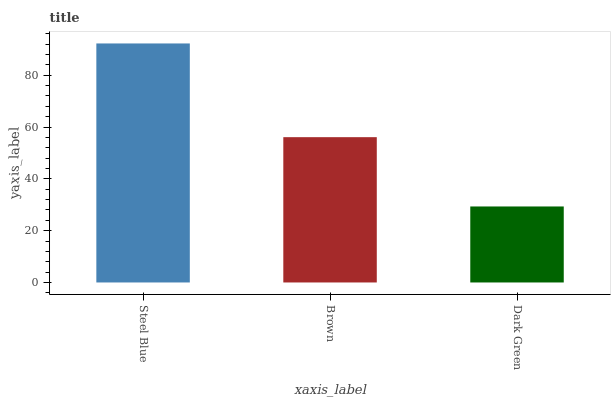Is Dark Green the minimum?
Answer yes or no. Yes. Is Steel Blue the maximum?
Answer yes or no. Yes. Is Brown the minimum?
Answer yes or no. No. Is Brown the maximum?
Answer yes or no. No. Is Steel Blue greater than Brown?
Answer yes or no. Yes. Is Brown less than Steel Blue?
Answer yes or no. Yes. Is Brown greater than Steel Blue?
Answer yes or no. No. Is Steel Blue less than Brown?
Answer yes or no. No. Is Brown the high median?
Answer yes or no. Yes. Is Brown the low median?
Answer yes or no. Yes. Is Dark Green the high median?
Answer yes or no. No. Is Steel Blue the low median?
Answer yes or no. No. 